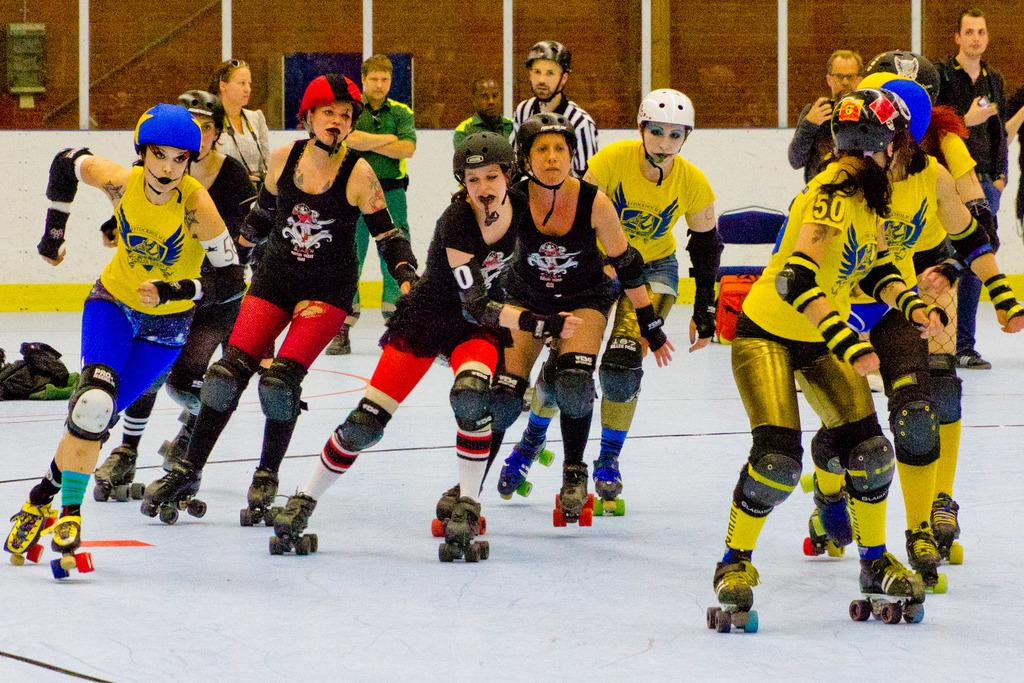What are the persons in the foreground of the image doing? The persons in the foreground of the image are skating on the floor. Are there any other people in the foreground of the image? Yes, some people are standing in the foreground. What can be seen in the background of the image? There is a wall visible in the background of the image. What time of day is it in the image, specifically in the afternoon? The provided facts do not mention the time of day, so it cannot be determined if it is afternoon in the image. 